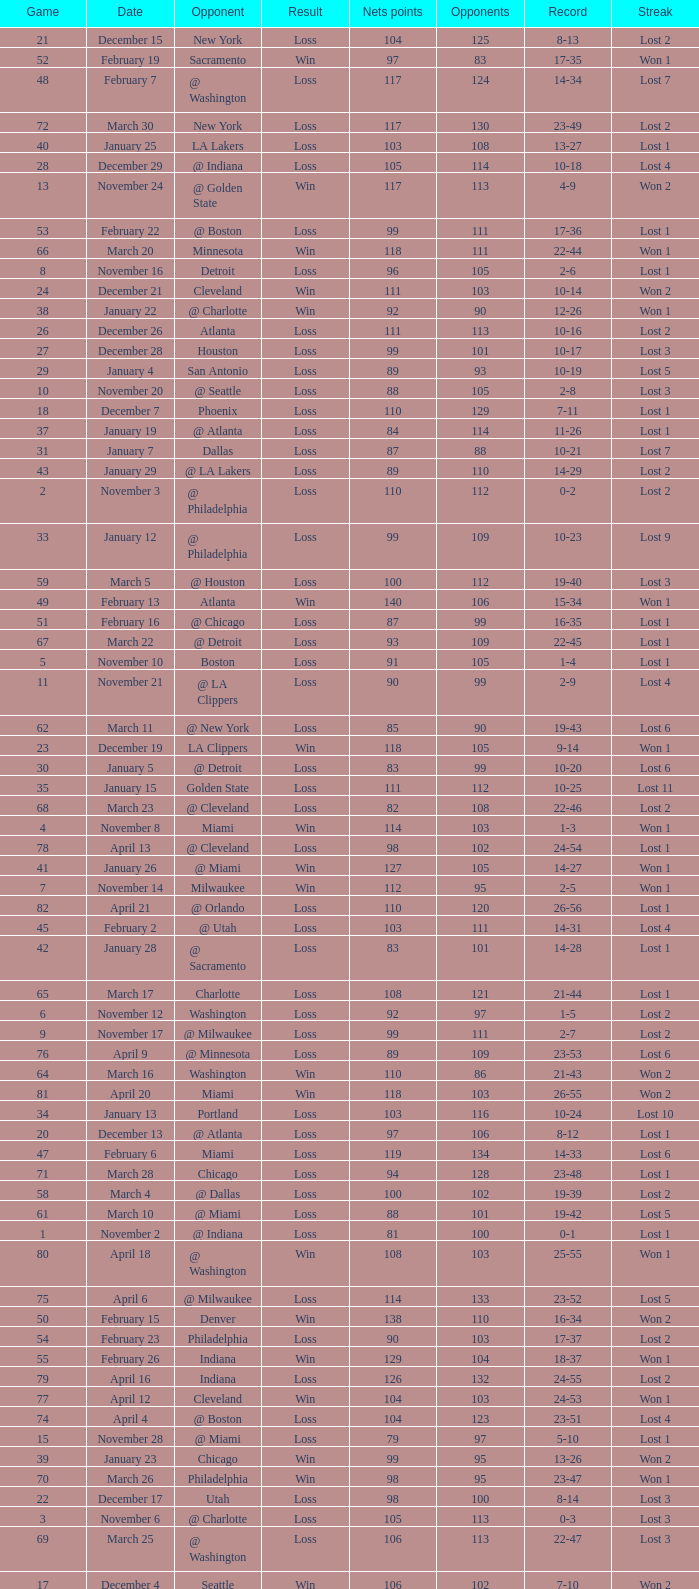In which game did the opponent score more than 103 and the record was 1-3? None. 